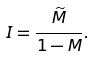<formula> <loc_0><loc_0><loc_500><loc_500>I = \frac { \widetilde { M } } { 1 - M } .</formula> 